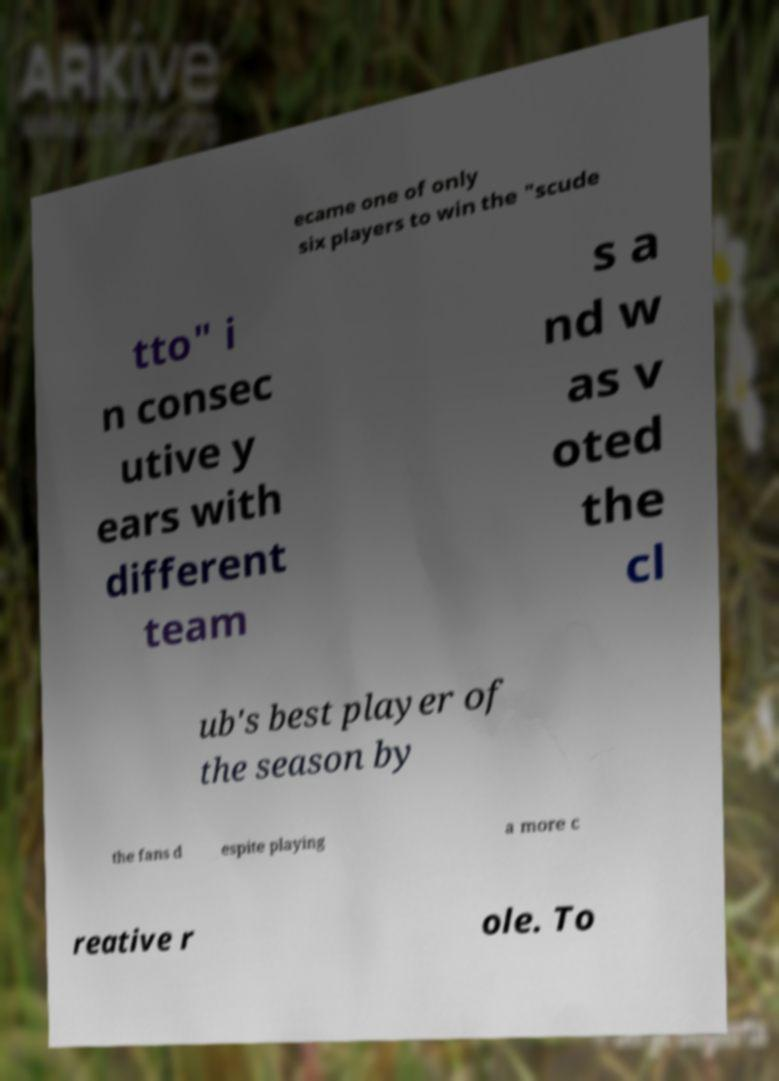Can you accurately transcribe the text from the provided image for me? ecame one of only six players to win the "scude tto" i n consec utive y ears with different team s a nd w as v oted the cl ub's best player of the season by the fans d espite playing a more c reative r ole. To 